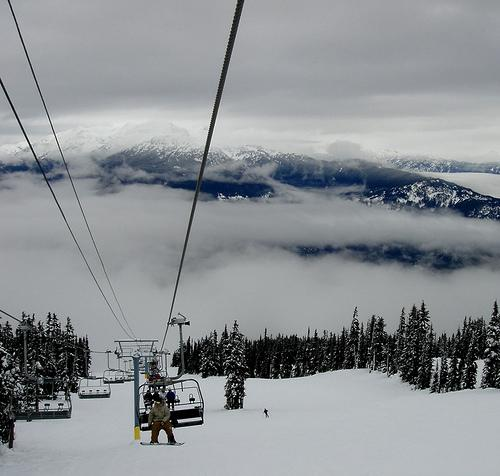Where does the carrier take the man to? mountain top 